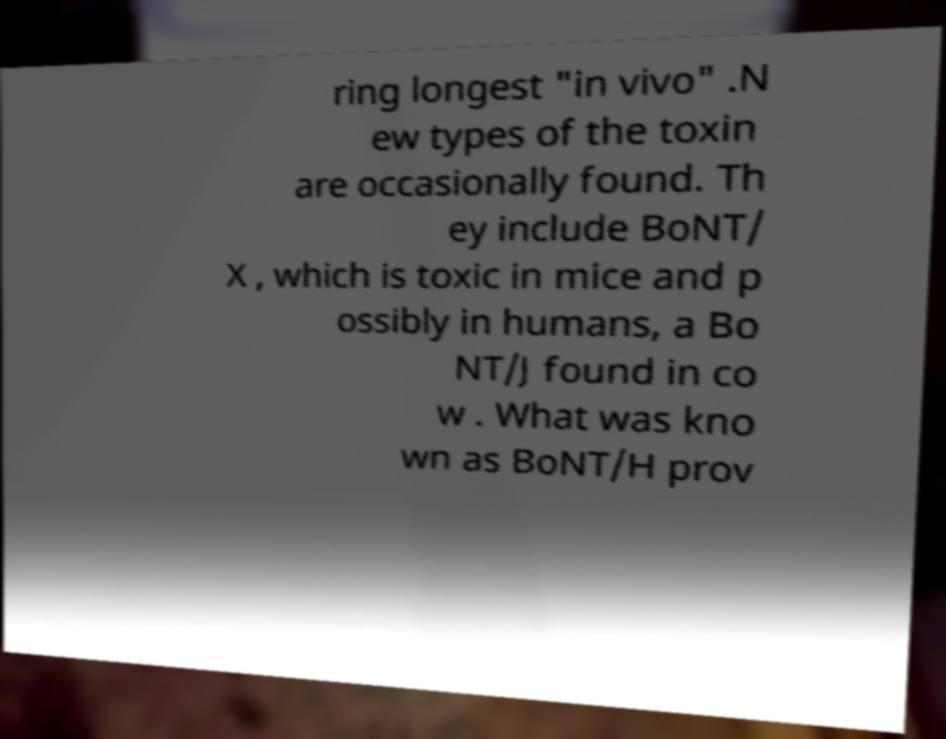There's text embedded in this image that I need extracted. Can you transcribe it verbatim? ring longest "in vivo" .N ew types of the toxin are occasionally found. Th ey include BoNT/ X , which is toxic in mice and p ossibly in humans, a Bo NT/J found in co w . What was kno wn as BoNT/H prov 